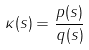<formula> <loc_0><loc_0><loc_500><loc_500>\kappa ( s ) = \frac { p ( s ) } { q ( s ) }</formula> 